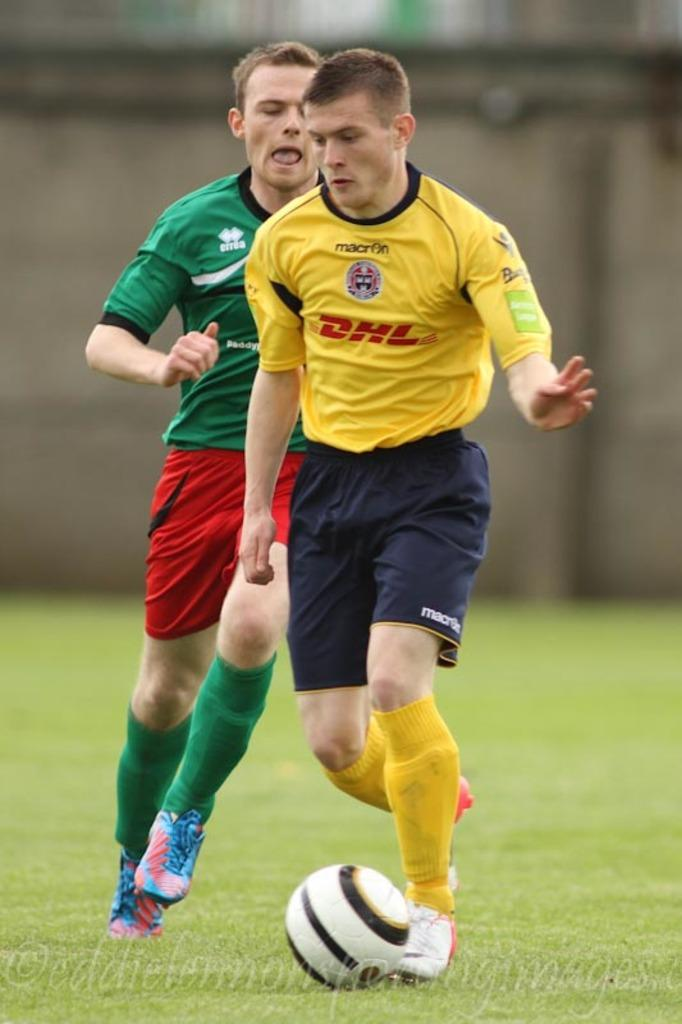How many people are in the image? There are two men in the image. What are the men doing in the image? The men are playing football. What type of surface is visible at the bottom of the image? There is grass at the bottom of the image. What object is essential for playing football in the image? There is a football in the image. Can you describe the background of the image? The background of the image is blurry. What additional information is provided at the bottom of the image? There is some text at the bottom of the image. What type of flight can be seen in the image? There is no flight visible in the image; it features two men playing football on a grassy surface. How many spoons are being used by the men in the image? There are no spoons present in the image; the men are playing football with a ball. 